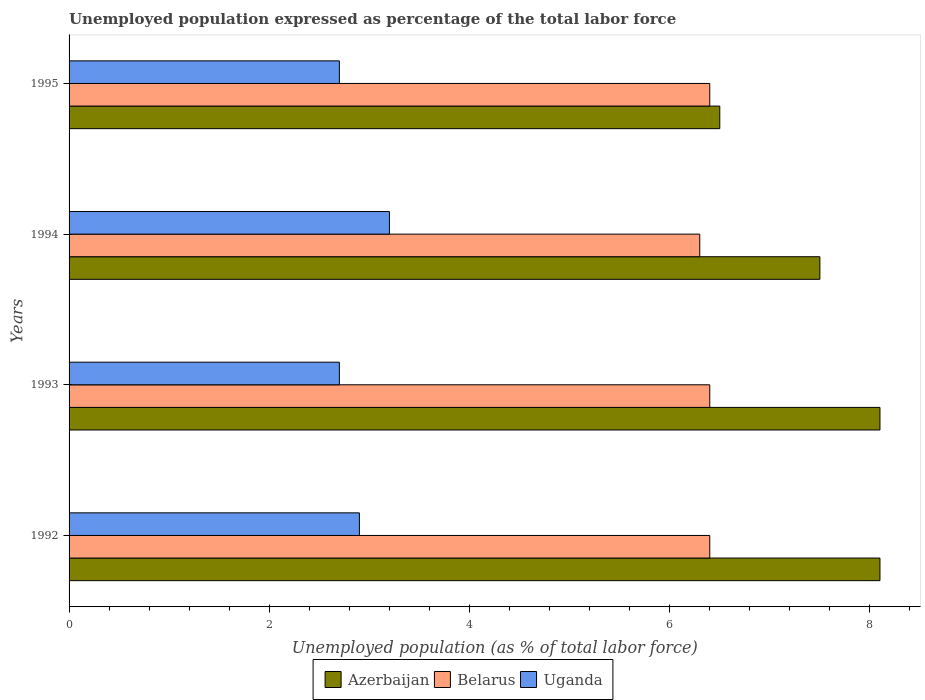How many different coloured bars are there?
Your answer should be compact. 3. Are the number of bars per tick equal to the number of legend labels?
Offer a very short reply. Yes. Are the number of bars on each tick of the Y-axis equal?
Offer a terse response. Yes. How many bars are there on the 4th tick from the bottom?
Provide a short and direct response. 3. Across all years, what is the maximum unemployment in in Azerbaijan?
Make the answer very short. 8.1. Across all years, what is the minimum unemployment in in Azerbaijan?
Keep it short and to the point. 6.5. What is the total unemployment in in Belarus in the graph?
Offer a very short reply. 25.5. What is the difference between the unemployment in in Uganda in 1993 and that in 1995?
Provide a succinct answer. 0. What is the difference between the unemployment in in Uganda in 1994 and the unemployment in in Azerbaijan in 1992?
Give a very brief answer. -4.9. What is the average unemployment in in Uganda per year?
Your response must be concise. 2.88. In the year 1994, what is the difference between the unemployment in in Uganda and unemployment in in Azerbaijan?
Your answer should be very brief. -4.3. What is the ratio of the unemployment in in Uganda in 1993 to that in 1994?
Provide a succinct answer. 0.84. What is the difference between the highest and the second highest unemployment in in Uganda?
Give a very brief answer. 0.3. What is the difference between the highest and the lowest unemployment in in Belarus?
Your answer should be very brief. 0.1. In how many years, is the unemployment in in Uganda greater than the average unemployment in in Uganda taken over all years?
Give a very brief answer. 2. Is the sum of the unemployment in in Belarus in 1992 and 1995 greater than the maximum unemployment in in Azerbaijan across all years?
Provide a succinct answer. Yes. What does the 3rd bar from the top in 1995 represents?
Offer a very short reply. Azerbaijan. What does the 1st bar from the bottom in 1992 represents?
Offer a very short reply. Azerbaijan. Is it the case that in every year, the sum of the unemployment in in Uganda and unemployment in in Belarus is greater than the unemployment in in Azerbaijan?
Your answer should be very brief. Yes. How many bars are there?
Your answer should be compact. 12. Are all the bars in the graph horizontal?
Your response must be concise. Yes. How many years are there in the graph?
Make the answer very short. 4. Are the values on the major ticks of X-axis written in scientific E-notation?
Offer a terse response. No. Does the graph contain any zero values?
Give a very brief answer. No. Does the graph contain grids?
Offer a very short reply. No. How are the legend labels stacked?
Make the answer very short. Horizontal. What is the title of the graph?
Keep it short and to the point. Unemployed population expressed as percentage of the total labor force. What is the label or title of the X-axis?
Make the answer very short. Unemployed population (as % of total labor force). What is the label or title of the Y-axis?
Ensure brevity in your answer.  Years. What is the Unemployed population (as % of total labor force) in Azerbaijan in 1992?
Provide a short and direct response. 8.1. What is the Unemployed population (as % of total labor force) in Belarus in 1992?
Your answer should be very brief. 6.4. What is the Unemployed population (as % of total labor force) in Uganda in 1992?
Provide a short and direct response. 2.9. What is the Unemployed population (as % of total labor force) in Azerbaijan in 1993?
Offer a very short reply. 8.1. What is the Unemployed population (as % of total labor force) of Belarus in 1993?
Make the answer very short. 6.4. What is the Unemployed population (as % of total labor force) in Uganda in 1993?
Make the answer very short. 2.7. What is the Unemployed population (as % of total labor force) of Azerbaijan in 1994?
Your answer should be compact. 7.5. What is the Unemployed population (as % of total labor force) of Belarus in 1994?
Provide a succinct answer. 6.3. What is the Unemployed population (as % of total labor force) of Uganda in 1994?
Provide a short and direct response. 3.2. What is the Unemployed population (as % of total labor force) of Azerbaijan in 1995?
Keep it short and to the point. 6.5. What is the Unemployed population (as % of total labor force) in Belarus in 1995?
Offer a terse response. 6.4. What is the Unemployed population (as % of total labor force) of Uganda in 1995?
Provide a short and direct response. 2.7. Across all years, what is the maximum Unemployed population (as % of total labor force) of Azerbaijan?
Your answer should be very brief. 8.1. Across all years, what is the maximum Unemployed population (as % of total labor force) of Belarus?
Offer a very short reply. 6.4. Across all years, what is the maximum Unemployed population (as % of total labor force) of Uganda?
Offer a terse response. 3.2. Across all years, what is the minimum Unemployed population (as % of total labor force) of Belarus?
Make the answer very short. 6.3. Across all years, what is the minimum Unemployed population (as % of total labor force) of Uganda?
Offer a terse response. 2.7. What is the total Unemployed population (as % of total labor force) in Azerbaijan in the graph?
Offer a very short reply. 30.2. What is the total Unemployed population (as % of total labor force) in Uganda in the graph?
Offer a terse response. 11.5. What is the difference between the Unemployed population (as % of total labor force) in Azerbaijan in 1992 and that in 1993?
Provide a succinct answer. 0. What is the difference between the Unemployed population (as % of total labor force) in Uganda in 1992 and that in 1993?
Your response must be concise. 0.2. What is the difference between the Unemployed population (as % of total labor force) of Belarus in 1992 and that in 1994?
Keep it short and to the point. 0.1. What is the difference between the Unemployed population (as % of total labor force) of Belarus in 1992 and that in 1995?
Keep it short and to the point. 0. What is the difference between the Unemployed population (as % of total labor force) of Uganda in 1992 and that in 1995?
Your answer should be very brief. 0.2. What is the difference between the Unemployed population (as % of total labor force) in Azerbaijan in 1993 and that in 1995?
Offer a very short reply. 1.6. What is the difference between the Unemployed population (as % of total labor force) in Uganda in 1994 and that in 1995?
Offer a terse response. 0.5. What is the difference between the Unemployed population (as % of total labor force) in Belarus in 1992 and the Unemployed population (as % of total labor force) in Uganda in 1993?
Your response must be concise. 3.7. What is the difference between the Unemployed population (as % of total labor force) of Azerbaijan in 1992 and the Unemployed population (as % of total labor force) of Belarus in 1994?
Ensure brevity in your answer.  1.8. What is the difference between the Unemployed population (as % of total labor force) in Belarus in 1992 and the Unemployed population (as % of total labor force) in Uganda in 1994?
Make the answer very short. 3.2. What is the difference between the Unemployed population (as % of total labor force) in Azerbaijan in 1992 and the Unemployed population (as % of total labor force) in Belarus in 1995?
Provide a succinct answer. 1.7. What is the difference between the Unemployed population (as % of total labor force) in Azerbaijan in 1992 and the Unemployed population (as % of total labor force) in Uganda in 1995?
Give a very brief answer. 5.4. What is the difference between the Unemployed population (as % of total labor force) of Azerbaijan in 1993 and the Unemployed population (as % of total labor force) of Uganda in 1995?
Your response must be concise. 5.4. What is the difference between the Unemployed population (as % of total labor force) of Belarus in 1993 and the Unemployed population (as % of total labor force) of Uganda in 1995?
Provide a short and direct response. 3.7. What is the difference between the Unemployed population (as % of total labor force) of Belarus in 1994 and the Unemployed population (as % of total labor force) of Uganda in 1995?
Provide a succinct answer. 3.6. What is the average Unemployed population (as % of total labor force) in Azerbaijan per year?
Give a very brief answer. 7.55. What is the average Unemployed population (as % of total labor force) in Belarus per year?
Your answer should be compact. 6.38. What is the average Unemployed population (as % of total labor force) in Uganda per year?
Offer a terse response. 2.88. In the year 1992, what is the difference between the Unemployed population (as % of total labor force) in Azerbaijan and Unemployed population (as % of total labor force) in Belarus?
Your answer should be very brief. 1.7. In the year 1992, what is the difference between the Unemployed population (as % of total labor force) of Belarus and Unemployed population (as % of total labor force) of Uganda?
Offer a terse response. 3.5. In the year 1993, what is the difference between the Unemployed population (as % of total labor force) of Azerbaijan and Unemployed population (as % of total labor force) of Belarus?
Keep it short and to the point. 1.7. In the year 1993, what is the difference between the Unemployed population (as % of total labor force) in Azerbaijan and Unemployed population (as % of total labor force) in Uganda?
Give a very brief answer. 5.4. In the year 1995, what is the difference between the Unemployed population (as % of total labor force) in Azerbaijan and Unemployed population (as % of total labor force) in Belarus?
Offer a terse response. 0.1. In the year 1995, what is the difference between the Unemployed population (as % of total labor force) of Belarus and Unemployed population (as % of total labor force) of Uganda?
Your response must be concise. 3.7. What is the ratio of the Unemployed population (as % of total labor force) in Uganda in 1992 to that in 1993?
Give a very brief answer. 1.07. What is the ratio of the Unemployed population (as % of total labor force) in Azerbaijan in 1992 to that in 1994?
Provide a short and direct response. 1.08. What is the ratio of the Unemployed population (as % of total labor force) of Belarus in 1992 to that in 1994?
Provide a succinct answer. 1.02. What is the ratio of the Unemployed population (as % of total labor force) of Uganda in 1992 to that in 1994?
Your response must be concise. 0.91. What is the ratio of the Unemployed population (as % of total labor force) in Azerbaijan in 1992 to that in 1995?
Your answer should be compact. 1.25. What is the ratio of the Unemployed population (as % of total labor force) of Uganda in 1992 to that in 1995?
Offer a very short reply. 1.07. What is the ratio of the Unemployed population (as % of total labor force) in Belarus in 1993 to that in 1994?
Your response must be concise. 1.02. What is the ratio of the Unemployed population (as % of total labor force) of Uganda in 1993 to that in 1994?
Keep it short and to the point. 0.84. What is the ratio of the Unemployed population (as % of total labor force) of Azerbaijan in 1993 to that in 1995?
Your response must be concise. 1.25. What is the ratio of the Unemployed population (as % of total labor force) of Azerbaijan in 1994 to that in 1995?
Your answer should be compact. 1.15. What is the ratio of the Unemployed population (as % of total labor force) of Belarus in 1994 to that in 1995?
Offer a very short reply. 0.98. What is the ratio of the Unemployed population (as % of total labor force) in Uganda in 1994 to that in 1995?
Give a very brief answer. 1.19. What is the difference between the highest and the second highest Unemployed population (as % of total labor force) of Uganda?
Your response must be concise. 0.3. What is the difference between the highest and the lowest Unemployed population (as % of total labor force) of Belarus?
Ensure brevity in your answer.  0.1. 